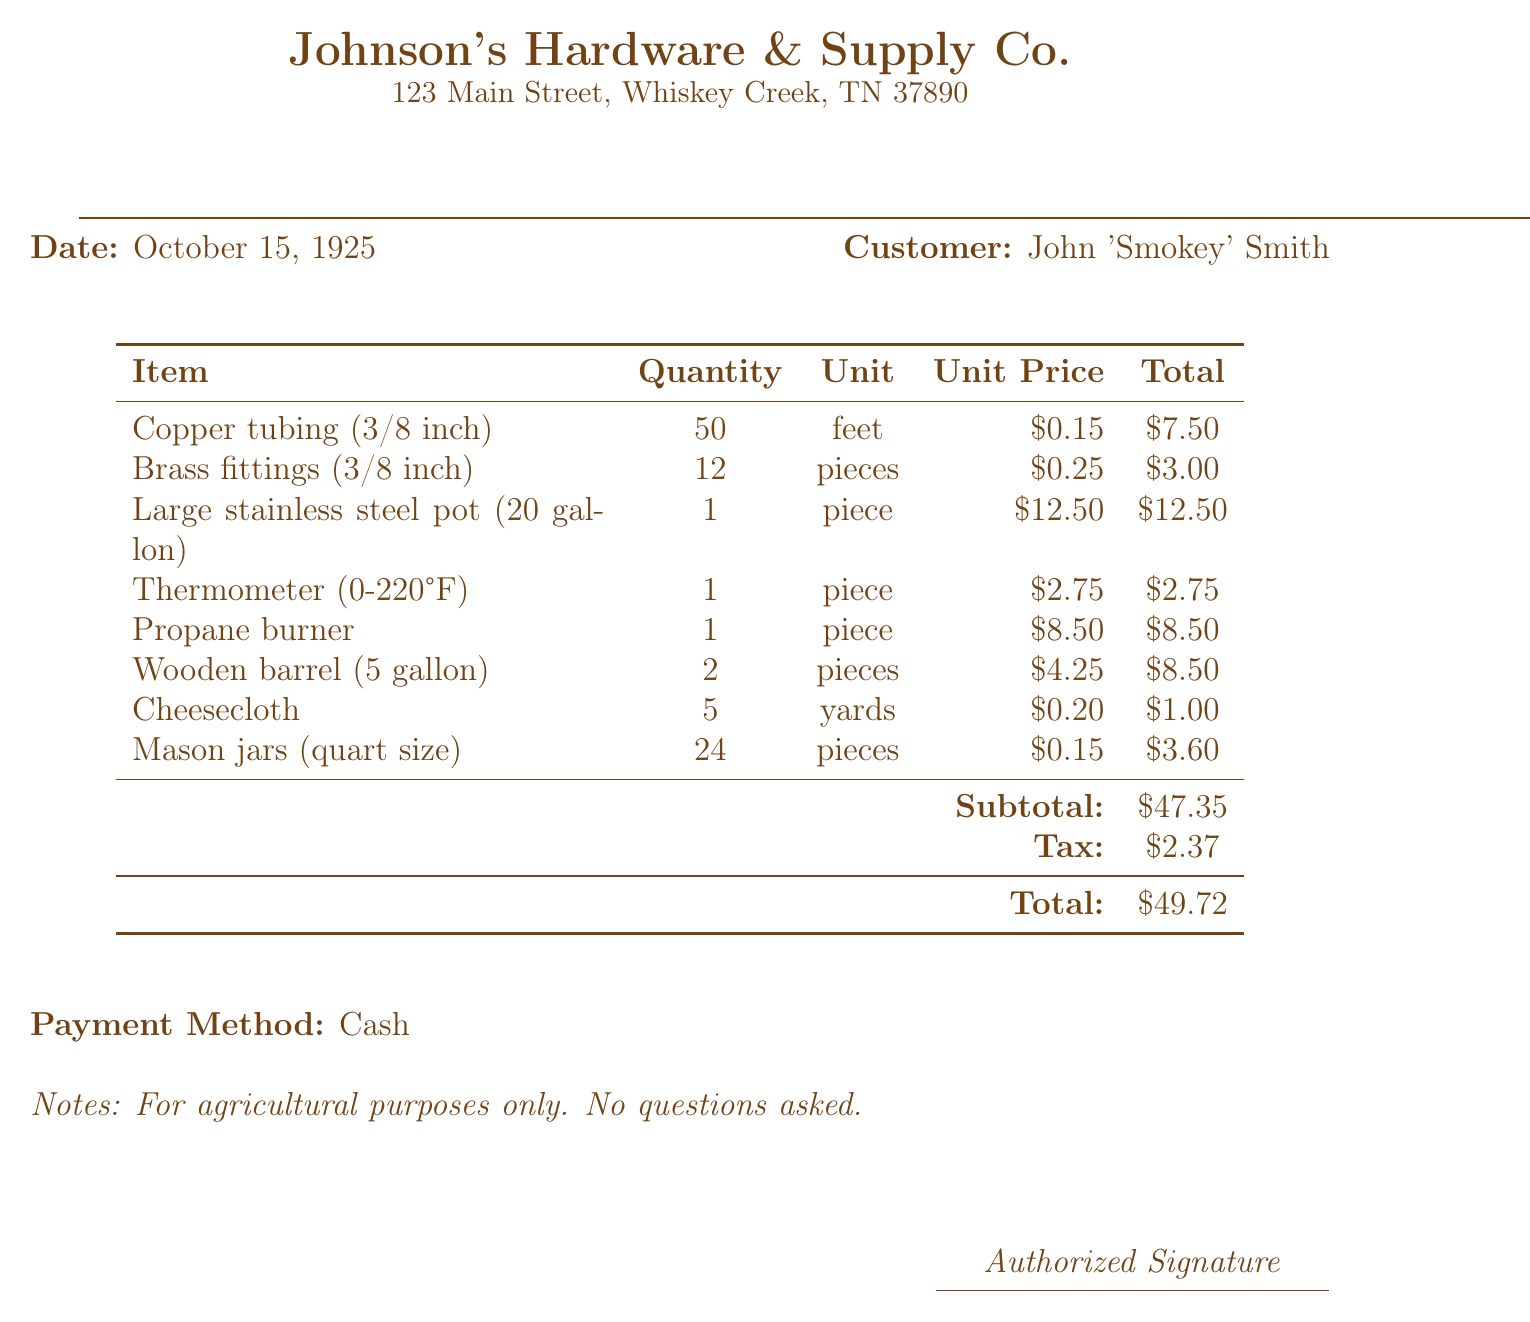What is the store name? The store name is listed prominently at the top of the document.
Answer: Johnson's Hardware & Supply Co What is the date of the receipt? The date is specified in the document as the day the transaction took place.
Answer: October 15, 1925 How many feet of copper tubing were purchased? The quantity of copper tubing is detailed in the itemized list.
Answer: 50 feet What is the total price for the brass fittings? The total price for brass fittings can be found in the itemized list of purchases.
Answer: 3.00 What is the subtotal amount before tax? The subtotal reflects the sum of all items before tax is applied.
Answer: 47.35 What is the tax amount on the purchase? The document specifies the tax amount applied to the subtotal.
Answer: 2.37 How many mason jars were bought? The quantity of mason jars is provided in the item list.
Answer: 24 pieces What is the payment method used for this purchase? The payment method is mentioned near the bottom of the receipt.
Answer: Cash What is noted about the purpose of the items? There is a specific note on the document regarding the intended use of the items purchased.
Answer: For agricultural purposes only. No questions asked 